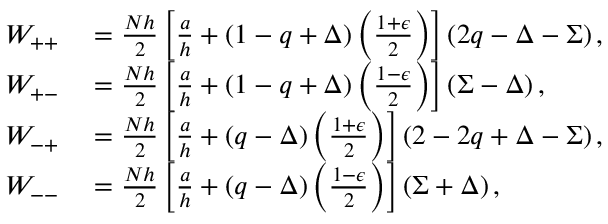Convert formula to latex. <formula><loc_0><loc_0><loc_500><loc_500>\begin{array} { r l } { W _ { + + } } & = \frac { N h } { 2 } \left [ \frac { a } { h } + \left ( 1 - q + \Delta \right ) \left ( \frac { 1 + \epsilon } { 2 } \right ) \right ] \left ( 2 q - \Delta - \Sigma \right ) , } \\ { W _ { + - } } & = \frac { N h } { 2 } \left [ \frac { a } { h } + \left ( 1 - q + \Delta \right ) \left ( \frac { 1 - \epsilon } { 2 } \right ) \right ] \left ( \Sigma - \Delta \right ) , } \\ { W _ { - + } } & = \frac { N h } { 2 } \left [ \frac { a } { h } + \left ( q - \Delta \right ) \left ( \frac { 1 + \epsilon } { 2 } \right ) \right ] \left ( 2 - 2 q + \Delta - \Sigma \right ) , } \\ { W _ { - - } } & = \frac { N h } { 2 } \left [ \frac { a } { h } + \left ( q - \Delta \right ) \left ( \frac { 1 - \epsilon } { 2 } \right ) \right ] \left ( \Sigma + \Delta \right ) , } \end{array}</formula> 